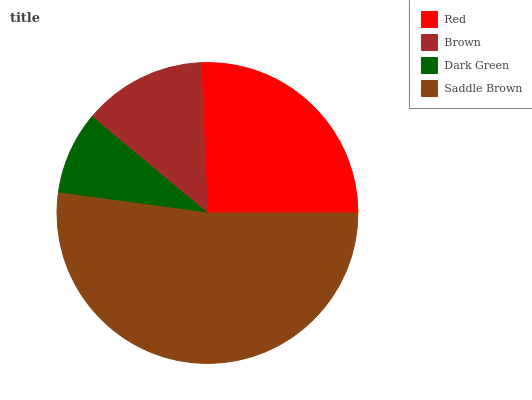Is Dark Green the minimum?
Answer yes or no. Yes. Is Saddle Brown the maximum?
Answer yes or no. Yes. Is Brown the minimum?
Answer yes or no. No. Is Brown the maximum?
Answer yes or no. No. Is Red greater than Brown?
Answer yes or no. Yes. Is Brown less than Red?
Answer yes or no. Yes. Is Brown greater than Red?
Answer yes or no. No. Is Red less than Brown?
Answer yes or no. No. Is Red the high median?
Answer yes or no. Yes. Is Brown the low median?
Answer yes or no. Yes. Is Brown the high median?
Answer yes or no. No. Is Saddle Brown the low median?
Answer yes or no. No. 